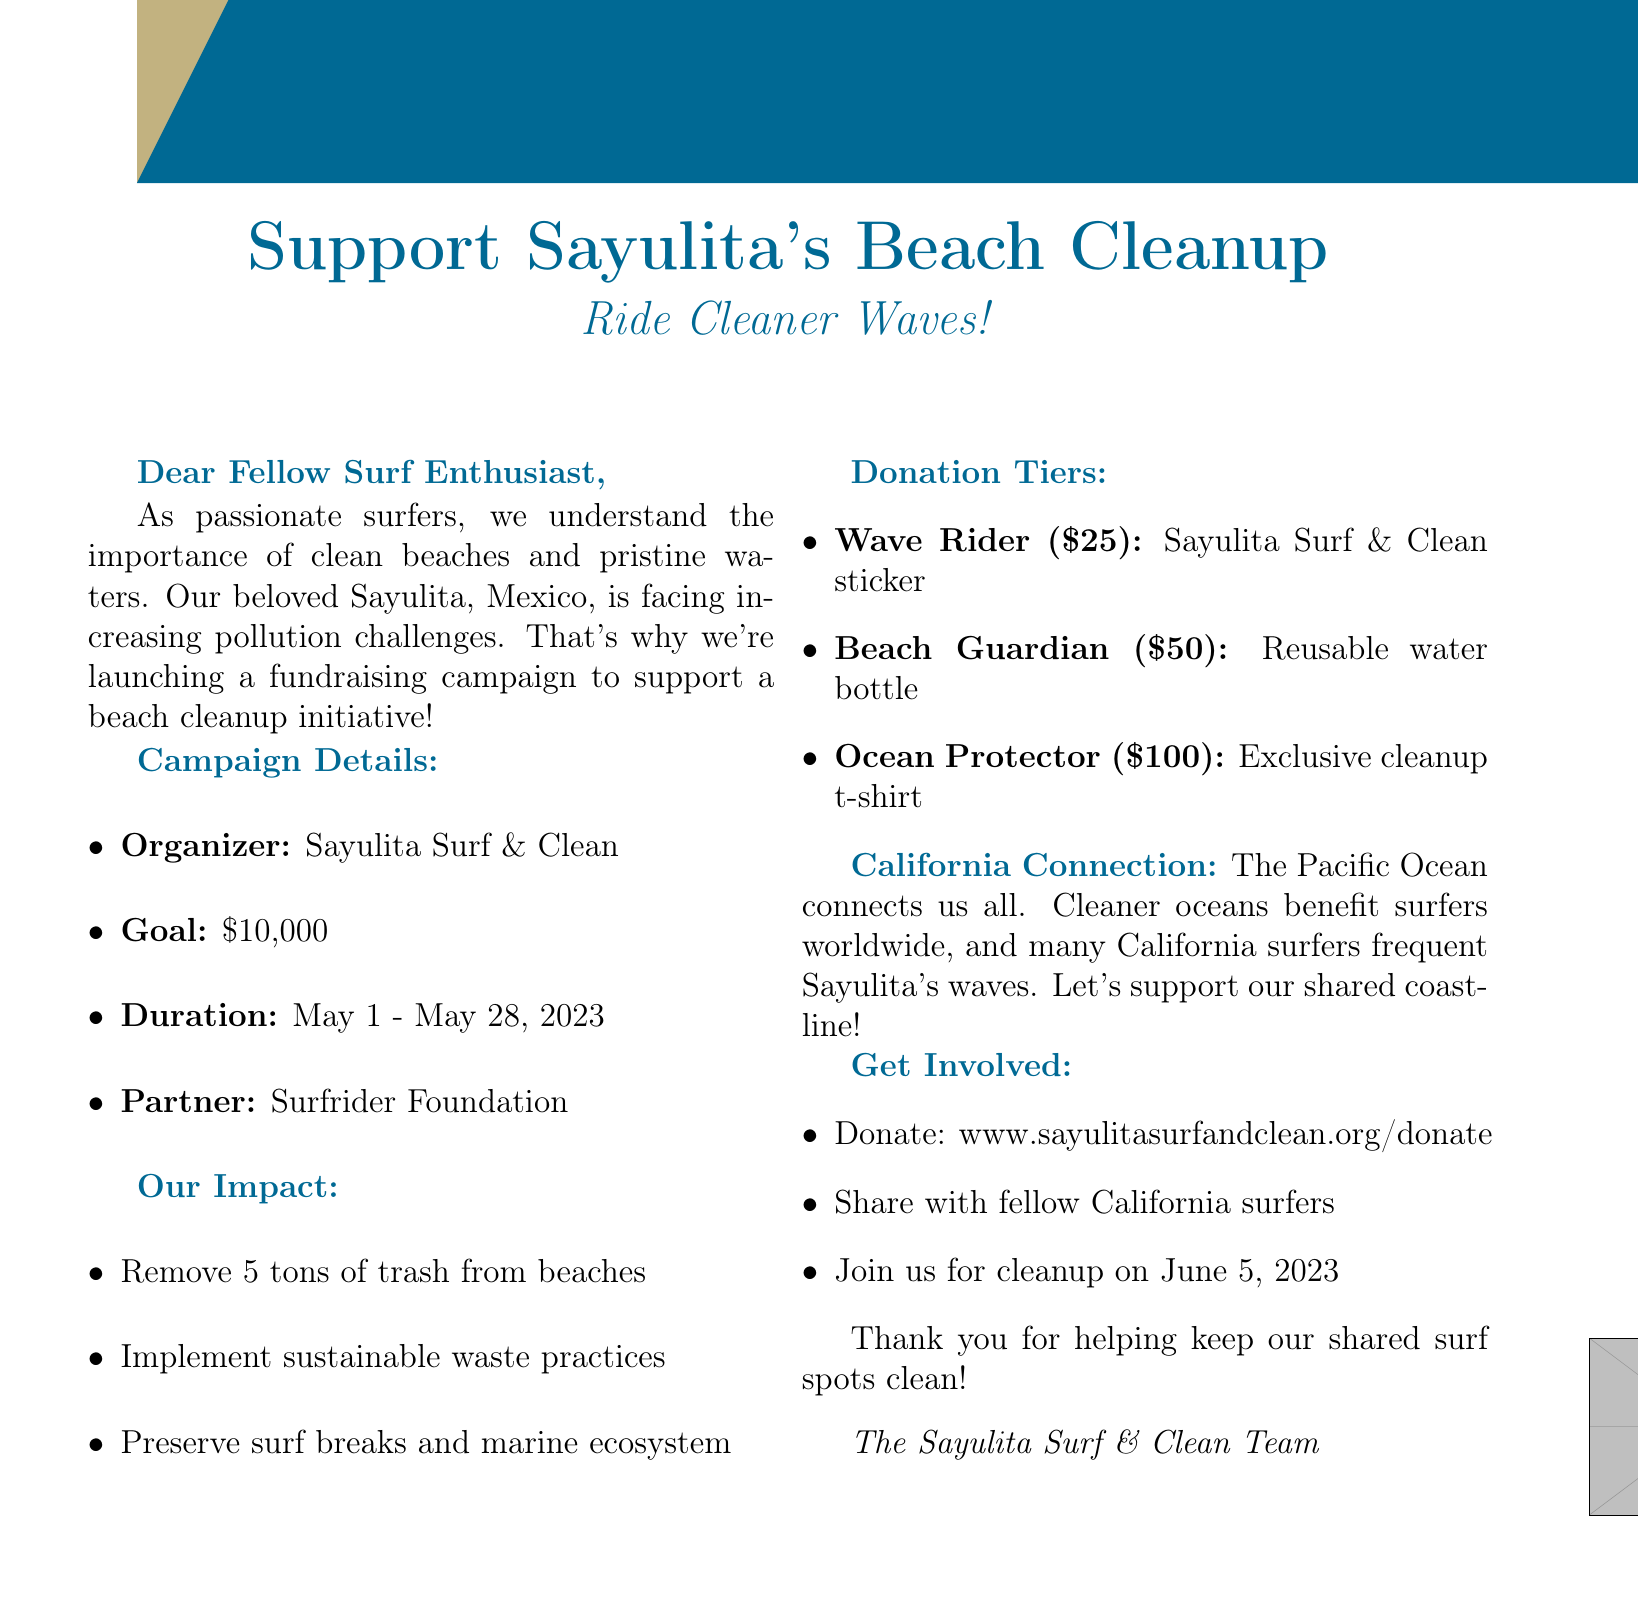What is the subject of the email? The subject clearly states the focus of the email, which is a fundraising campaign for beach cleanup support in Sayulita.
Answer: Support Sayulita's Beach Cleanup: Ride Cleaner Waves! Who is organizing the campaign? The organizer's name is mentioned in the campaign details, specifying who is responsible for the initiative.
Answer: Sayulita Surf & Clean What is the fundraising goal? The document states the monetary target for the fundraising campaign, which is crucial for understanding the initiative's financial needs.
Answer: $10,000 What is the duration of the campaign? The document provides the specific dates during which the fundraising campaign will take place.
Answer: 4 weeks (May 1 - May 28, 2023) How much trash is expected to be removed? The impact section outlines the immediate goal of the cleanup initiative in terms of trash removal.
Answer: 5 tons What benefit does the beach cleanup initiative provide? The document highlights the long-term benefits of this campaign for the environment and surf spots.
Answer: Preserve the surf breaks and marine ecosystem What is one of the donation tiers? The donation tiers section lists various levels of contributions and their corresponding rewards.
Answer: Wave Rider When is the cleanup event scheduled? The call-to-action section states the date of the cleanup event, encouraging participation.
Answer: June 5, 2023 How can people donate? The call to action provides a URL for making donations, which is essential for participation in the fundraising effort.
Answer: www.sayulitasurfandclean.org/donate 